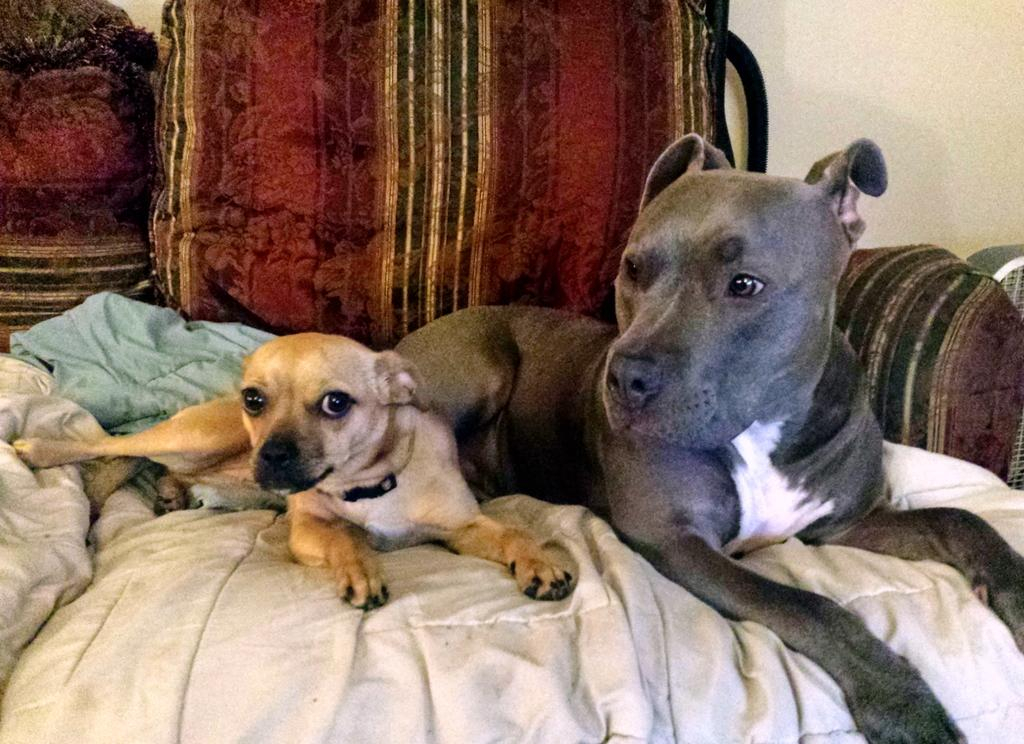How many dogs are in the image? There are two dogs in the image. Where are the dogs located? The dogs are on a sofa in the image. What else can be seen in the image besides the dogs? There are blankets and chairs visible in the image. What is the background of the image? There is a wall in the image, which suggests it is likely taken in a room. What type of fiction is the dogs reading on the sofa? The dogs are not reading any fiction in the image; they are simply sitting on the sofa. 